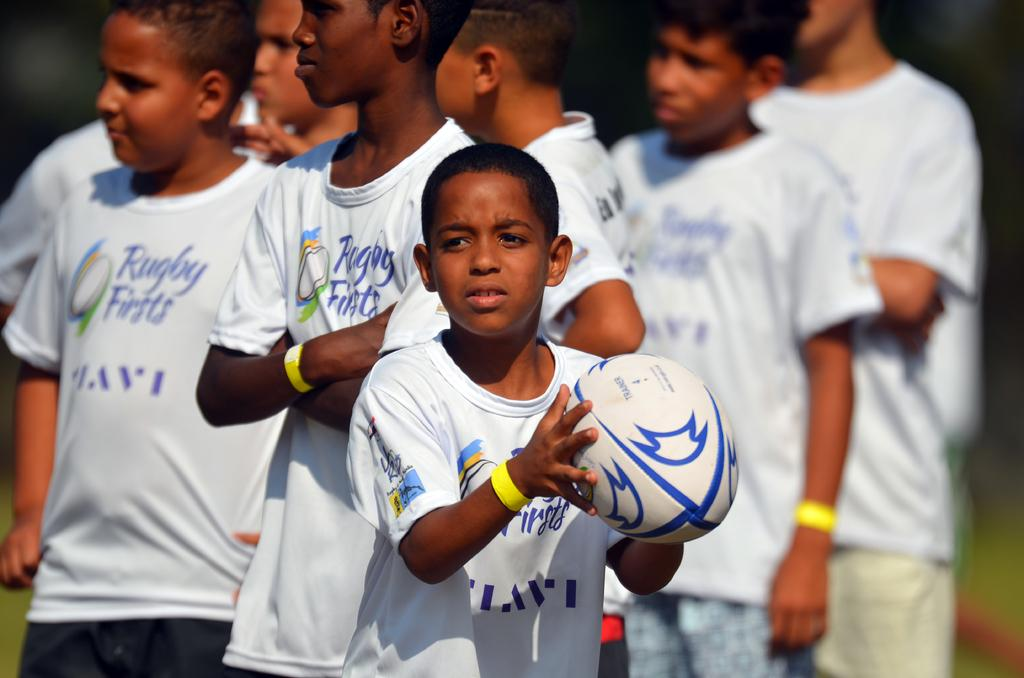<image>
Summarize the visual content of the image. A group of kids wear shirts for a rugby team. 